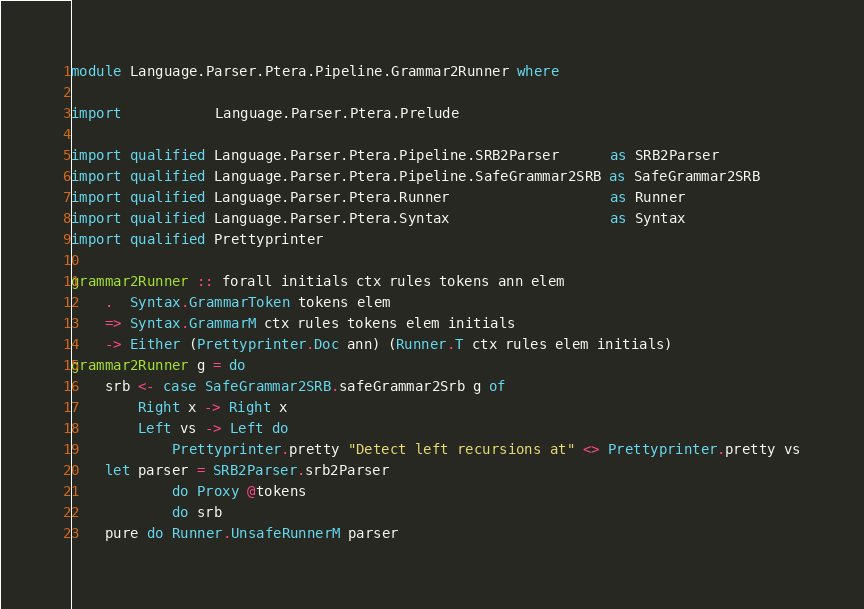Convert code to text. <code><loc_0><loc_0><loc_500><loc_500><_Haskell_>module Language.Parser.Ptera.Pipeline.Grammar2Runner where

import           Language.Parser.Ptera.Prelude

import qualified Language.Parser.Ptera.Pipeline.SRB2Parser      as SRB2Parser
import qualified Language.Parser.Ptera.Pipeline.SafeGrammar2SRB as SafeGrammar2SRB
import qualified Language.Parser.Ptera.Runner                   as Runner
import qualified Language.Parser.Ptera.Syntax                   as Syntax
import qualified Prettyprinter

grammar2Runner :: forall initials ctx rules tokens ann elem
    .  Syntax.GrammarToken tokens elem
    => Syntax.GrammarM ctx rules tokens elem initials
    -> Either (Prettyprinter.Doc ann) (Runner.T ctx rules elem initials)
grammar2Runner g = do
    srb <- case SafeGrammar2SRB.safeGrammar2Srb g of
        Right x -> Right x
        Left vs -> Left do
            Prettyprinter.pretty "Detect left recursions at" <> Prettyprinter.pretty vs
    let parser = SRB2Parser.srb2Parser
            do Proxy @tokens
            do srb
    pure do Runner.UnsafeRunnerM parser
</code> 